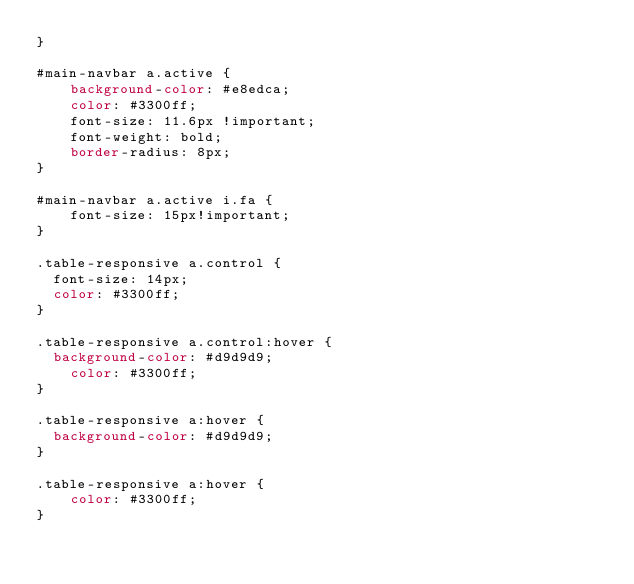Convert code to text. <code><loc_0><loc_0><loc_500><loc_500><_CSS_>}

#main-navbar a.active {
    background-color: #e8edca;
    color: #3300ff;
    font-size: 11.6px !important;
    font-weight: bold;
    border-radius: 8px;
}

#main-navbar a.active i.fa {
    font-size: 15px!important;
}

.table-responsive a.control {
	font-size: 14px;
	color: #3300ff;
}

.table-responsive a.control:hover {
	background-color: #d9d9d9;
    color: #3300ff;
}

.table-responsive a:hover {
	background-color: #d9d9d9;
}

.table-responsive a:hover {
    color: #3300ff;
}
</code> 